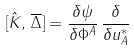Convert formula to latex. <formula><loc_0><loc_0><loc_500><loc_500>[ \hat { K } , \, \overline { \Delta } ] = \frac { \delta \psi } { \delta \Phi ^ { A } } \, \frac { \delta } { \delta u ^ { * } _ { A } }</formula> 